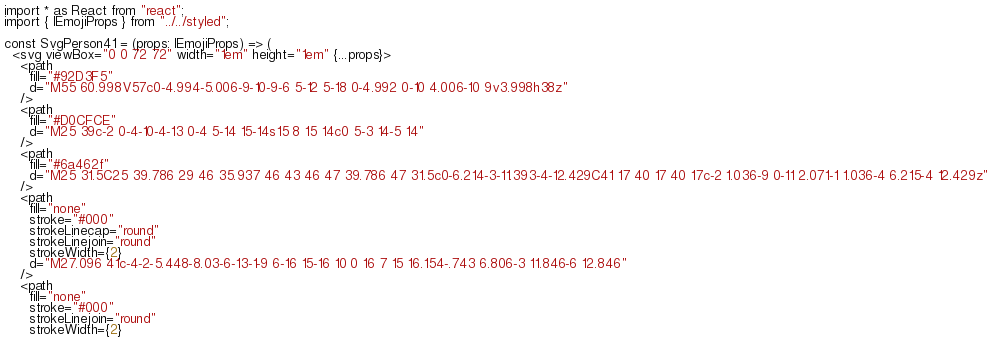Convert code to text. <code><loc_0><loc_0><loc_500><loc_500><_TypeScript_>import * as React from "react";
import { IEmojiProps } from "../../styled";

const SvgPerson41 = (props: IEmojiProps) => (
  <svg viewBox="0 0 72 72" width="1em" height="1em" {...props}>
    <path
      fill="#92D3F5"
      d="M55 60.998V57c0-4.994-5.006-9-10-9-6 5-12 5-18 0-4.992 0-10 4.006-10 9v3.998h38z"
    />
    <path
      fill="#D0CFCE"
      d="M25 39c-2 0-4-10-4-13 0-4 5-14 15-14s15 8 15 14c0 5-3 14-5 14"
    />
    <path
      fill="#6a462f"
      d="M25 31.5C25 39.786 29 46 35.937 46 43 46 47 39.786 47 31.5c0-6.214-3-11.393-4-12.429C41 17 40 17 40 17c-2 1.036-9 0-11 2.071-1 1.036-4 6.215-4 12.429z"
    />
    <path
      fill="none"
      stroke="#000"
      strokeLinecap="round"
      strokeLinejoin="round"
      strokeWidth={2}
      d="M27.096 41c-4-2-5.448-8.03-6-13-1-9 6-16 15-16 10 0 16 7 15 16.154-.743 6.806-3 11.846-6 12.846"
    />
    <path
      fill="none"
      stroke="#000"
      strokeLinejoin="round"
      strokeWidth={2}</code> 